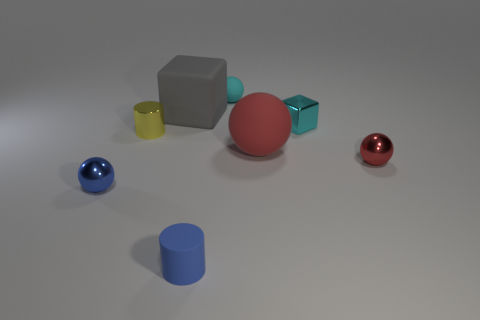Add 2 tiny cyan shiny things. How many objects exist? 10 Subtract all cylinders. How many objects are left? 6 Add 6 tiny shiny cylinders. How many tiny shiny cylinders exist? 7 Subtract 0 yellow balls. How many objects are left? 8 Subtract all big gray matte spheres. Subtract all blue things. How many objects are left? 6 Add 2 large gray blocks. How many large gray blocks are left? 3 